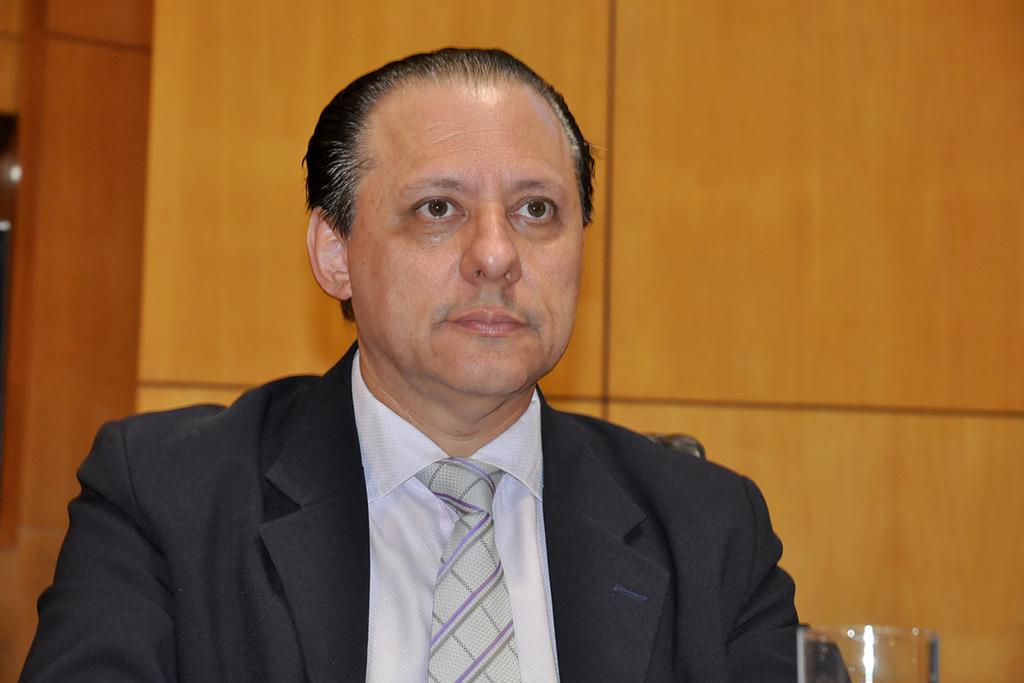Who is present in the image? There is a man in the picture. What is the man wearing on his upper body? The man is wearing a blazer, a shirt, and a tie. What is in front of the man? There is a glass in front of the man. What can be seen behind the man? There is a wooden wall behind the man. What type of battle is taking place in the image? There is no battle present in the image; it features a man sitting in front of a wooden wall with a glass in front of him. Can you tell me the color of the kitty in the image? There is no kitty present in the image. 